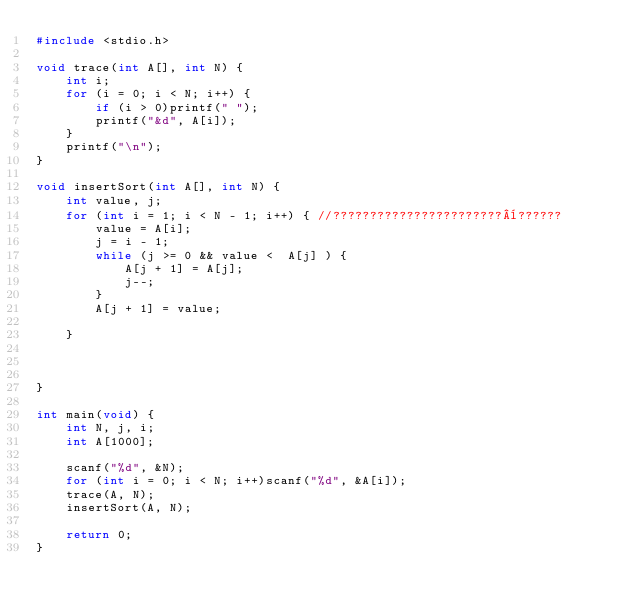Convert code to text. <code><loc_0><loc_0><loc_500><loc_500><_C_>#include <stdio.h>

void trace(int A[], int N) {
	int i;
	for (i = 0; i < N; i++) {
		if (i > 0)printf(" ");
		printf("&d", A[i]);
	}
	printf("\n");
}

void insertSort(int A[], int N) {
	int value, j;
	for (int i = 1; i < N - 1; i++) { //???????????????????????¨??????
		value = A[i];
		j = i - 1;
		while (j >= 0 && value <  A[j] ) {
			A[j + 1] = A[j];
			j--;
		}
		A[j + 1] = value;

	}



}

int main(void) {
	int N, j, i;
	int A[1000];

	scanf("%d", &N);
	for (int i = 0; i < N; i++)scanf("%d", &A[i]);
	trace(A, N);
	insertSort(A, N);

	return 0;
}</code> 